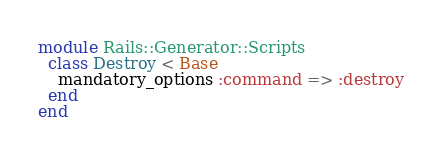Convert code to text. <code><loc_0><loc_0><loc_500><loc_500><_Ruby_>module Rails::Generator::Scripts
  class Destroy < Base
    mandatory_options :command => :destroy
  end
end
</code> 